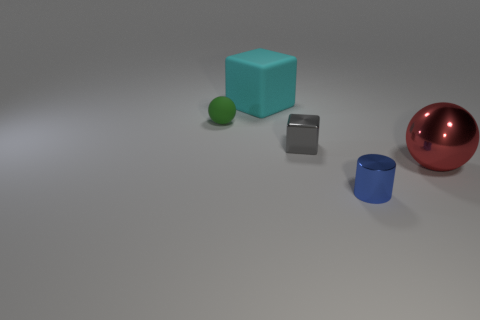What colors are present in the objects within the image? The image features objects in a variety of colors: there is a blue cube, a green sphere, a reflective silver cylinder, and a glossy red sphere. 